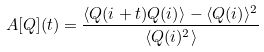Convert formula to latex. <formula><loc_0><loc_0><loc_500><loc_500>A [ Q ] ( t ) = \frac { \langle Q ( i + t ) Q ( i ) \rangle - \langle Q ( i ) \rangle ^ { 2 } } { \langle Q ( i ) ^ { 2 } \rangle }</formula> 